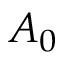Convert formula to latex. <formula><loc_0><loc_0><loc_500><loc_500>A _ { 0 }</formula> 